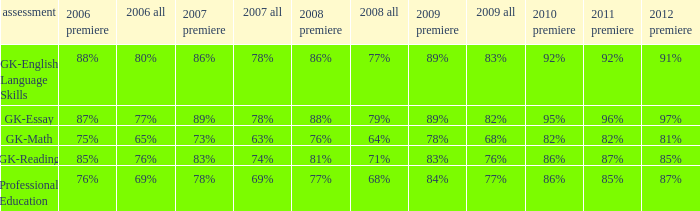What is the percentage for all in 2008 when all in 2007 was 69%? 68%. 